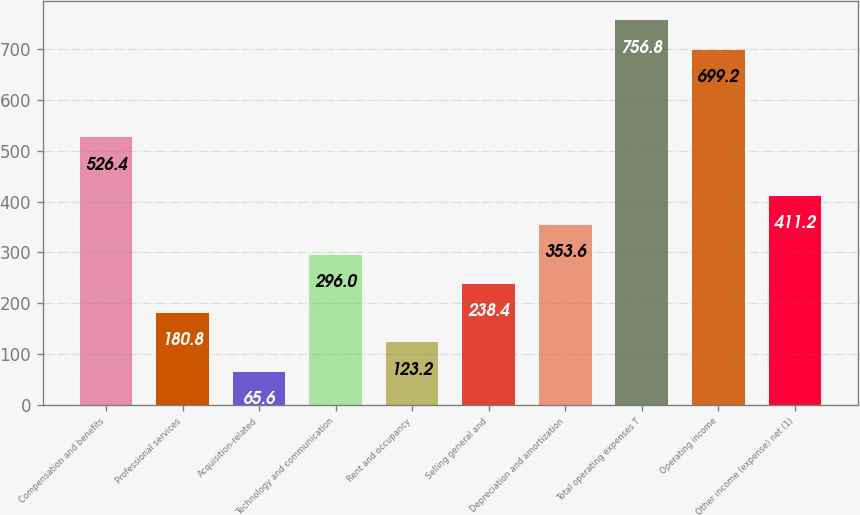Convert chart to OTSL. <chart><loc_0><loc_0><loc_500><loc_500><bar_chart><fcel>Compensation and benefits<fcel>Professional services<fcel>Acquisition-related<fcel>Technology and communication<fcel>Rent and occupancy<fcel>Selling general and<fcel>Depreciation and amortization<fcel>Total operating expenses T<fcel>Operating income<fcel>Other income (expense) net (1)<nl><fcel>526.4<fcel>180.8<fcel>65.6<fcel>296<fcel>123.2<fcel>238.4<fcel>353.6<fcel>756.8<fcel>699.2<fcel>411.2<nl></chart> 